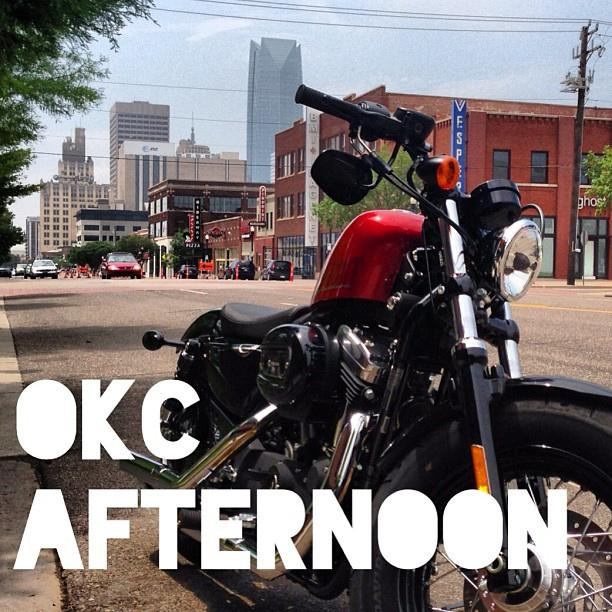What kind of building is the one with the black sign?

Choices:
A) gym
B) restaurant
C) bank
D) hospital restaurant 